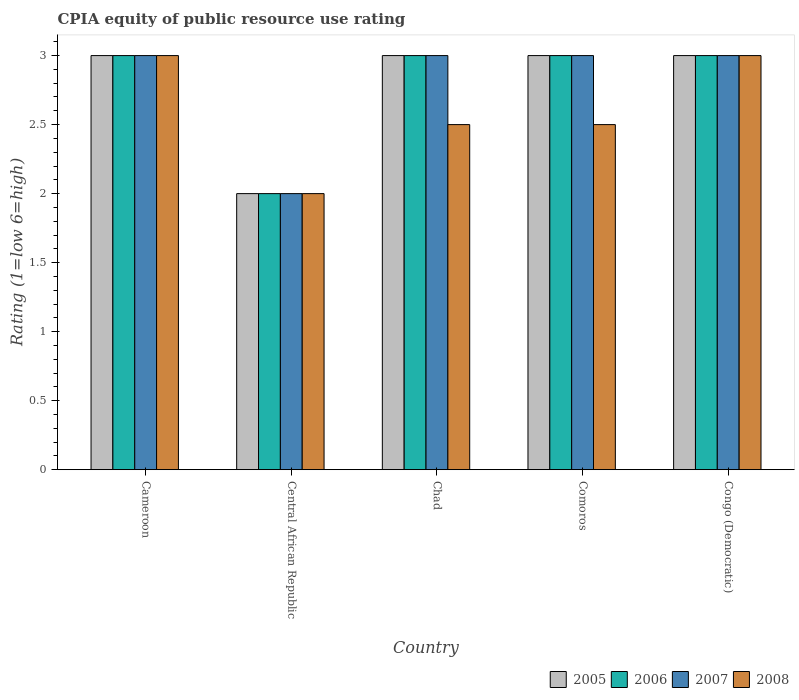Are the number of bars per tick equal to the number of legend labels?
Provide a succinct answer. Yes. Are the number of bars on each tick of the X-axis equal?
Your answer should be very brief. Yes. What is the label of the 2nd group of bars from the left?
Your response must be concise. Central African Republic. Across all countries, what is the maximum CPIA rating in 2008?
Your response must be concise. 3. In which country was the CPIA rating in 2008 maximum?
Keep it short and to the point. Cameroon. In which country was the CPIA rating in 2008 minimum?
Offer a terse response. Central African Republic. What is the total CPIA rating in 2008 in the graph?
Your answer should be compact. 13. What is the difference between the CPIA rating in 2007 in Cameroon and that in Chad?
Your answer should be compact. 0. What is the difference between the CPIA rating in 2006 in Congo (Democratic) and the CPIA rating in 2005 in Comoros?
Give a very brief answer. 0. What is the average CPIA rating in 2005 per country?
Offer a very short reply. 2.8. What is the difference between the CPIA rating of/in 2006 and CPIA rating of/in 2007 in Congo (Democratic)?
Ensure brevity in your answer.  0. In how many countries, is the CPIA rating in 2005 greater than 1.4?
Your response must be concise. 5. What is the ratio of the CPIA rating in 2007 in Cameroon to that in Congo (Democratic)?
Provide a succinct answer. 1. What does the 3rd bar from the left in Comoros represents?
Offer a terse response. 2007. What does the 2nd bar from the right in Central African Republic represents?
Make the answer very short. 2007. Is it the case that in every country, the sum of the CPIA rating in 2006 and CPIA rating in 2007 is greater than the CPIA rating in 2008?
Your answer should be very brief. Yes. How many bars are there?
Keep it short and to the point. 20. How many countries are there in the graph?
Give a very brief answer. 5. Does the graph contain grids?
Your answer should be compact. No. How many legend labels are there?
Provide a short and direct response. 4. What is the title of the graph?
Offer a very short reply. CPIA equity of public resource use rating. What is the label or title of the Y-axis?
Your answer should be very brief. Rating (1=low 6=high). What is the Rating (1=low 6=high) of 2006 in Cameroon?
Your response must be concise. 3. What is the Rating (1=low 6=high) in 2005 in Central African Republic?
Make the answer very short. 2. What is the Rating (1=low 6=high) in 2005 in Chad?
Keep it short and to the point. 3. What is the Rating (1=low 6=high) of 2007 in Chad?
Your answer should be compact. 3. What is the Rating (1=low 6=high) of 2008 in Chad?
Your response must be concise. 2.5. What is the Rating (1=low 6=high) of 2005 in Congo (Democratic)?
Provide a short and direct response. 3. What is the Rating (1=low 6=high) in 2006 in Congo (Democratic)?
Give a very brief answer. 3. Across all countries, what is the maximum Rating (1=low 6=high) in 2005?
Make the answer very short. 3. Across all countries, what is the maximum Rating (1=low 6=high) in 2006?
Keep it short and to the point. 3. Across all countries, what is the maximum Rating (1=low 6=high) of 2007?
Your response must be concise. 3. Across all countries, what is the minimum Rating (1=low 6=high) of 2007?
Keep it short and to the point. 2. What is the total Rating (1=low 6=high) in 2005 in the graph?
Keep it short and to the point. 14. What is the total Rating (1=low 6=high) in 2007 in the graph?
Your answer should be compact. 14. What is the total Rating (1=low 6=high) of 2008 in the graph?
Make the answer very short. 13. What is the difference between the Rating (1=low 6=high) of 2006 in Cameroon and that in Central African Republic?
Provide a succinct answer. 1. What is the difference between the Rating (1=low 6=high) of 2005 in Cameroon and that in Chad?
Your response must be concise. 0. What is the difference between the Rating (1=low 6=high) of 2006 in Cameroon and that in Chad?
Ensure brevity in your answer.  0. What is the difference between the Rating (1=low 6=high) of 2007 in Cameroon and that in Chad?
Ensure brevity in your answer.  0. What is the difference between the Rating (1=low 6=high) of 2006 in Cameroon and that in Comoros?
Offer a very short reply. 0. What is the difference between the Rating (1=low 6=high) in 2008 in Cameroon and that in Comoros?
Your response must be concise. 0.5. What is the difference between the Rating (1=low 6=high) of 2005 in Cameroon and that in Congo (Democratic)?
Provide a succinct answer. 0. What is the difference between the Rating (1=low 6=high) of 2006 in Cameroon and that in Congo (Democratic)?
Give a very brief answer. 0. What is the difference between the Rating (1=low 6=high) in 2005 in Central African Republic and that in Chad?
Your response must be concise. -1. What is the difference between the Rating (1=low 6=high) of 2008 in Central African Republic and that in Chad?
Your answer should be compact. -0.5. What is the difference between the Rating (1=low 6=high) in 2007 in Central African Republic and that in Comoros?
Offer a very short reply. -1. What is the difference between the Rating (1=low 6=high) of 2005 in Central African Republic and that in Congo (Democratic)?
Your response must be concise. -1. What is the difference between the Rating (1=low 6=high) in 2007 in Central African Republic and that in Congo (Democratic)?
Make the answer very short. -1. What is the difference between the Rating (1=low 6=high) in 2006 in Chad and that in Comoros?
Your answer should be compact. 0. What is the difference between the Rating (1=low 6=high) of 2007 in Chad and that in Comoros?
Provide a short and direct response. 0. What is the difference between the Rating (1=low 6=high) of 2008 in Chad and that in Comoros?
Your response must be concise. 0. What is the difference between the Rating (1=low 6=high) in 2007 in Chad and that in Congo (Democratic)?
Your response must be concise. 0. What is the difference between the Rating (1=low 6=high) in 2008 in Chad and that in Congo (Democratic)?
Your answer should be very brief. -0.5. What is the difference between the Rating (1=low 6=high) of 2005 in Comoros and that in Congo (Democratic)?
Provide a short and direct response. 0. What is the difference between the Rating (1=low 6=high) of 2008 in Comoros and that in Congo (Democratic)?
Provide a short and direct response. -0.5. What is the difference between the Rating (1=low 6=high) of 2005 in Cameroon and the Rating (1=low 6=high) of 2006 in Central African Republic?
Make the answer very short. 1. What is the difference between the Rating (1=low 6=high) in 2005 in Cameroon and the Rating (1=low 6=high) in 2008 in Central African Republic?
Offer a terse response. 1. What is the difference between the Rating (1=low 6=high) of 2005 in Cameroon and the Rating (1=low 6=high) of 2006 in Chad?
Make the answer very short. 0. What is the difference between the Rating (1=low 6=high) of 2005 in Cameroon and the Rating (1=low 6=high) of 2007 in Chad?
Provide a succinct answer. 0. What is the difference between the Rating (1=low 6=high) of 2006 in Cameroon and the Rating (1=low 6=high) of 2008 in Chad?
Offer a very short reply. 0.5. What is the difference between the Rating (1=low 6=high) of 2005 in Cameroon and the Rating (1=low 6=high) of 2007 in Comoros?
Your answer should be compact. 0. What is the difference between the Rating (1=low 6=high) of 2005 in Cameroon and the Rating (1=low 6=high) of 2008 in Comoros?
Your answer should be very brief. 0.5. What is the difference between the Rating (1=low 6=high) in 2006 in Cameroon and the Rating (1=low 6=high) in 2007 in Comoros?
Your response must be concise. 0. What is the difference between the Rating (1=low 6=high) in 2005 in Cameroon and the Rating (1=low 6=high) in 2006 in Congo (Democratic)?
Give a very brief answer. 0. What is the difference between the Rating (1=low 6=high) of 2005 in Cameroon and the Rating (1=low 6=high) of 2008 in Congo (Democratic)?
Your answer should be very brief. 0. What is the difference between the Rating (1=low 6=high) of 2006 in Cameroon and the Rating (1=low 6=high) of 2007 in Congo (Democratic)?
Your answer should be compact. 0. What is the difference between the Rating (1=low 6=high) in 2007 in Cameroon and the Rating (1=low 6=high) in 2008 in Congo (Democratic)?
Your answer should be compact. 0. What is the difference between the Rating (1=low 6=high) in 2005 in Central African Republic and the Rating (1=low 6=high) in 2006 in Chad?
Provide a succinct answer. -1. What is the difference between the Rating (1=low 6=high) of 2005 in Central African Republic and the Rating (1=low 6=high) of 2007 in Chad?
Keep it short and to the point. -1. What is the difference between the Rating (1=low 6=high) of 2005 in Central African Republic and the Rating (1=low 6=high) of 2006 in Comoros?
Your answer should be compact. -1. What is the difference between the Rating (1=low 6=high) in 2006 in Central African Republic and the Rating (1=low 6=high) in 2007 in Comoros?
Provide a short and direct response. -1. What is the difference between the Rating (1=low 6=high) of 2006 in Central African Republic and the Rating (1=low 6=high) of 2008 in Comoros?
Ensure brevity in your answer.  -0.5. What is the difference between the Rating (1=low 6=high) of 2007 in Central African Republic and the Rating (1=low 6=high) of 2008 in Comoros?
Offer a terse response. -0.5. What is the difference between the Rating (1=low 6=high) in 2005 in Central African Republic and the Rating (1=low 6=high) in 2006 in Congo (Democratic)?
Ensure brevity in your answer.  -1. What is the difference between the Rating (1=low 6=high) in 2005 in Central African Republic and the Rating (1=low 6=high) in 2007 in Congo (Democratic)?
Keep it short and to the point. -1. What is the difference between the Rating (1=low 6=high) of 2006 in Central African Republic and the Rating (1=low 6=high) of 2007 in Congo (Democratic)?
Provide a succinct answer. -1. What is the difference between the Rating (1=low 6=high) of 2007 in Central African Republic and the Rating (1=low 6=high) of 2008 in Congo (Democratic)?
Your answer should be compact. -1. What is the difference between the Rating (1=low 6=high) in 2005 in Chad and the Rating (1=low 6=high) in 2006 in Comoros?
Provide a succinct answer. 0. What is the difference between the Rating (1=low 6=high) in 2005 in Chad and the Rating (1=low 6=high) in 2007 in Comoros?
Keep it short and to the point. 0. What is the difference between the Rating (1=low 6=high) of 2005 in Chad and the Rating (1=low 6=high) of 2008 in Comoros?
Keep it short and to the point. 0.5. What is the difference between the Rating (1=low 6=high) in 2006 in Chad and the Rating (1=low 6=high) in 2007 in Comoros?
Your response must be concise. 0. What is the difference between the Rating (1=low 6=high) in 2005 in Chad and the Rating (1=low 6=high) in 2007 in Congo (Democratic)?
Your response must be concise. 0. What is the difference between the Rating (1=low 6=high) of 2006 in Chad and the Rating (1=low 6=high) of 2008 in Congo (Democratic)?
Provide a short and direct response. 0. What is the difference between the Rating (1=low 6=high) in 2007 in Chad and the Rating (1=low 6=high) in 2008 in Congo (Democratic)?
Offer a very short reply. 0. What is the difference between the Rating (1=low 6=high) in 2005 in Comoros and the Rating (1=low 6=high) in 2006 in Congo (Democratic)?
Give a very brief answer. 0. What is the difference between the Rating (1=low 6=high) of 2006 in Comoros and the Rating (1=low 6=high) of 2007 in Congo (Democratic)?
Your answer should be very brief. 0. What is the average Rating (1=low 6=high) of 2006 per country?
Provide a short and direct response. 2.8. What is the average Rating (1=low 6=high) in 2007 per country?
Your response must be concise. 2.8. What is the average Rating (1=low 6=high) in 2008 per country?
Give a very brief answer. 2.6. What is the difference between the Rating (1=low 6=high) of 2005 and Rating (1=low 6=high) of 2008 in Cameroon?
Keep it short and to the point. 0. What is the difference between the Rating (1=low 6=high) of 2006 and Rating (1=low 6=high) of 2007 in Cameroon?
Offer a terse response. 0. What is the difference between the Rating (1=low 6=high) in 2005 and Rating (1=low 6=high) in 2008 in Central African Republic?
Your answer should be compact. 0. What is the difference between the Rating (1=low 6=high) in 2007 and Rating (1=low 6=high) in 2008 in Central African Republic?
Keep it short and to the point. 0. What is the difference between the Rating (1=low 6=high) of 2005 and Rating (1=low 6=high) of 2006 in Chad?
Provide a succinct answer. 0. What is the difference between the Rating (1=low 6=high) in 2005 and Rating (1=low 6=high) in 2007 in Chad?
Offer a terse response. 0. What is the difference between the Rating (1=low 6=high) of 2007 and Rating (1=low 6=high) of 2008 in Chad?
Offer a very short reply. 0.5. What is the difference between the Rating (1=low 6=high) of 2005 and Rating (1=low 6=high) of 2006 in Comoros?
Your response must be concise. 0. What is the difference between the Rating (1=low 6=high) of 2005 and Rating (1=low 6=high) of 2008 in Comoros?
Your answer should be very brief. 0.5. What is the difference between the Rating (1=low 6=high) of 2005 and Rating (1=low 6=high) of 2007 in Congo (Democratic)?
Give a very brief answer. 0. What is the difference between the Rating (1=low 6=high) of 2005 and Rating (1=low 6=high) of 2008 in Congo (Democratic)?
Provide a short and direct response. 0. What is the difference between the Rating (1=low 6=high) of 2006 and Rating (1=low 6=high) of 2007 in Congo (Democratic)?
Make the answer very short. 0. What is the difference between the Rating (1=low 6=high) in 2007 and Rating (1=low 6=high) in 2008 in Congo (Democratic)?
Offer a very short reply. 0. What is the ratio of the Rating (1=low 6=high) in 2005 in Cameroon to that in Central African Republic?
Give a very brief answer. 1.5. What is the ratio of the Rating (1=low 6=high) of 2006 in Cameroon to that in Central African Republic?
Give a very brief answer. 1.5. What is the ratio of the Rating (1=low 6=high) in 2007 in Cameroon to that in Central African Republic?
Make the answer very short. 1.5. What is the ratio of the Rating (1=low 6=high) of 2008 in Cameroon to that in Central African Republic?
Provide a short and direct response. 1.5. What is the ratio of the Rating (1=low 6=high) in 2005 in Cameroon to that in Chad?
Keep it short and to the point. 1. What is the ratio of the Rating (1=low 6=high) in 2006 in Cameroon to that in Chad?
Keep it short and to the point. 1. What is the ratio of the Rating (1=low 6=high) of 2007 in Cameroon to that in Chad?
Provide a succinct answer. 1. What is the ratio of the Rating (1=low 6=high) in 2008 in Cameroon to that in Chad?
Provide a succinct answer. 1.2. What is the ratio of the Rating (1=low 6=high) in 2007 in Cameroon to that in Comoros?
Offer a very short reply. 1. What is the ratio of the Rating (1=low 6=high) of 2006 in Cameroon to that in Congo (Democratic)?
Offer a terse response. 1. What is the ratio of the Rating (1=low 6=high) in 2007 in Cameroon to that in Congo (Democratic)?
Offer a very short reply. 1. What is the ratio of the Rating (1=low 6=high) of 2008 in Cameroon to that in Congo (Democratic)?
Offer a very short reply. 1. What is the ratio of the Rating (1=low 6=high) in 2006 in Central African Republic to that in Comoros?
Give a very brief answer. 0.67. What is the ratio of the Rating (1=low 6=high) of 2007 in Central African Republic to that in Comoros?
Ensure brevity in your answer.  0.67. What is the ratio of the Rating (1=low 6=high) in 2006 in Central African Republic to that in Congo (Democratic)?
Provide a short and direct response. 0.67. What is the ratio of the Rating (1=low 6=high) in 2008 in Central African Republic to that in Congo (Democratic)?
Provide a short and direct response. 0.67. What is the ratio of the Rating (1=low 6=high) in 2006 in Chad to that in Comoros?
Make the answer very short. 1. What is the ratio of the Rating (1=low 6=high) in 2006 in Chad to that in Congo (Democratic)?
Offer a terse response. 1. What is the ratio of the Rating (1=low 6=high) in 2008 in Chad to that in Congo (Democratic)?
Keep it short and to the point. 0.83. What is the ratio of the Rating (1=low 6=high) of 2005 in Comoros to that in Congo (Democratic)?
Make the answer very short. 1. What is the ratio of the Rating (1=low 6=high) in 2007 in Comoros to that in Congo (Democratic)?
Your response must be concise. 1. What is the ratio of the Rating (1=low 6=high) of 2008 in Comoros to that in Congo (Democratic)?
Offer a terse response. 0.83. What is the difference between the highest and the second highest Rating (1=low 6=high) in 2007?
Your response must be concise. 0. What is the difference between the highest and the second highest Rating (1=low 6=high) of 2008?
Make the answer very short. 0. What is the difference between the highest and the lowest Rating (1=low 6=high) of 2005?
Make the answer very short. 1. What is the difference between the highest and the lowest Rating (1=low 6=high) in 2006?
Keep it short and to the point. 1. 